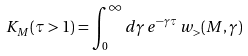<formula> <loc_0><loc_0><loc_500><loc_500>K _ { M } ( \tau > 1 ) = \int _ { 0 } ^ { \infty } d \gamma \, e ^ { - \gamma \tau } \, w _ { > } ( M , \gamma )</formula> 